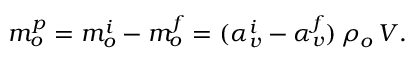Convert formula to latex. <formula><loc_0><loc_0><loc_500><loc_500>m _ { o } ^ { p } = m _ { o } ^ { i } - m _ { o } ^ { f } = ( \alpha _ { v } ^ { i } - \alpha _ { v } ^ { f } ) \, \rho _ { o } \, V .</formula> 